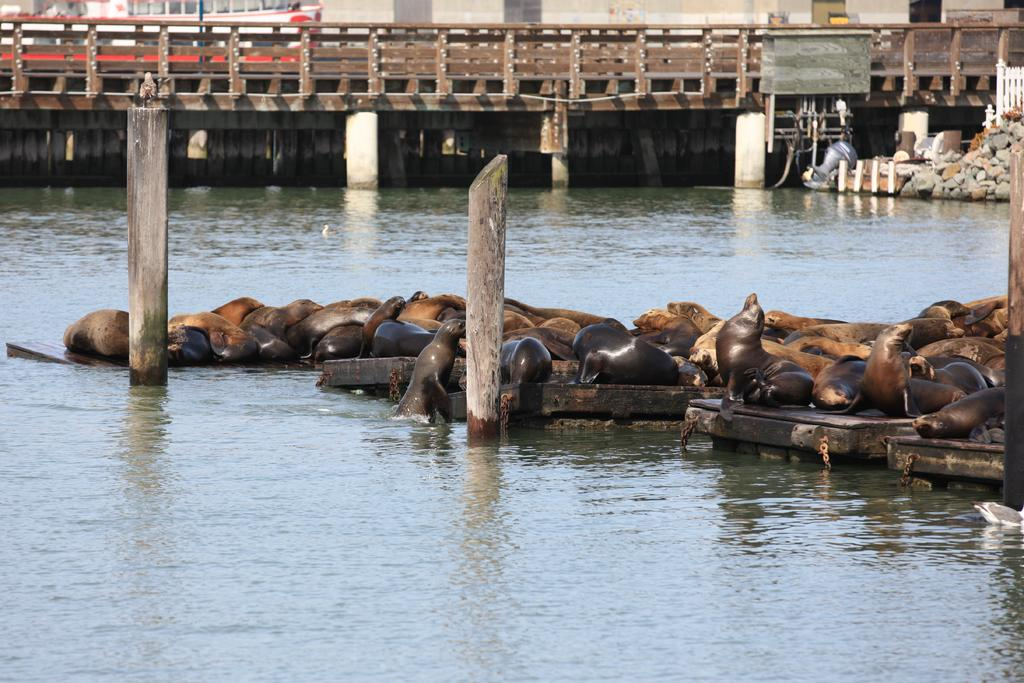What type of animals are present in the image? There are seals in the image. What objects can be seen in the image besides the seals? There are wooden poles visible in the image. What natural element is present in the image? There is water visible in the image. What structures can be seen in the background of the image? There is a bridge, a pole, stones, and a wall in the background of the image. What type of wine is being served on the stage in the image? There is no stage or wine present in the image; it features seals, wooden poles, water, and various structures in the background. 